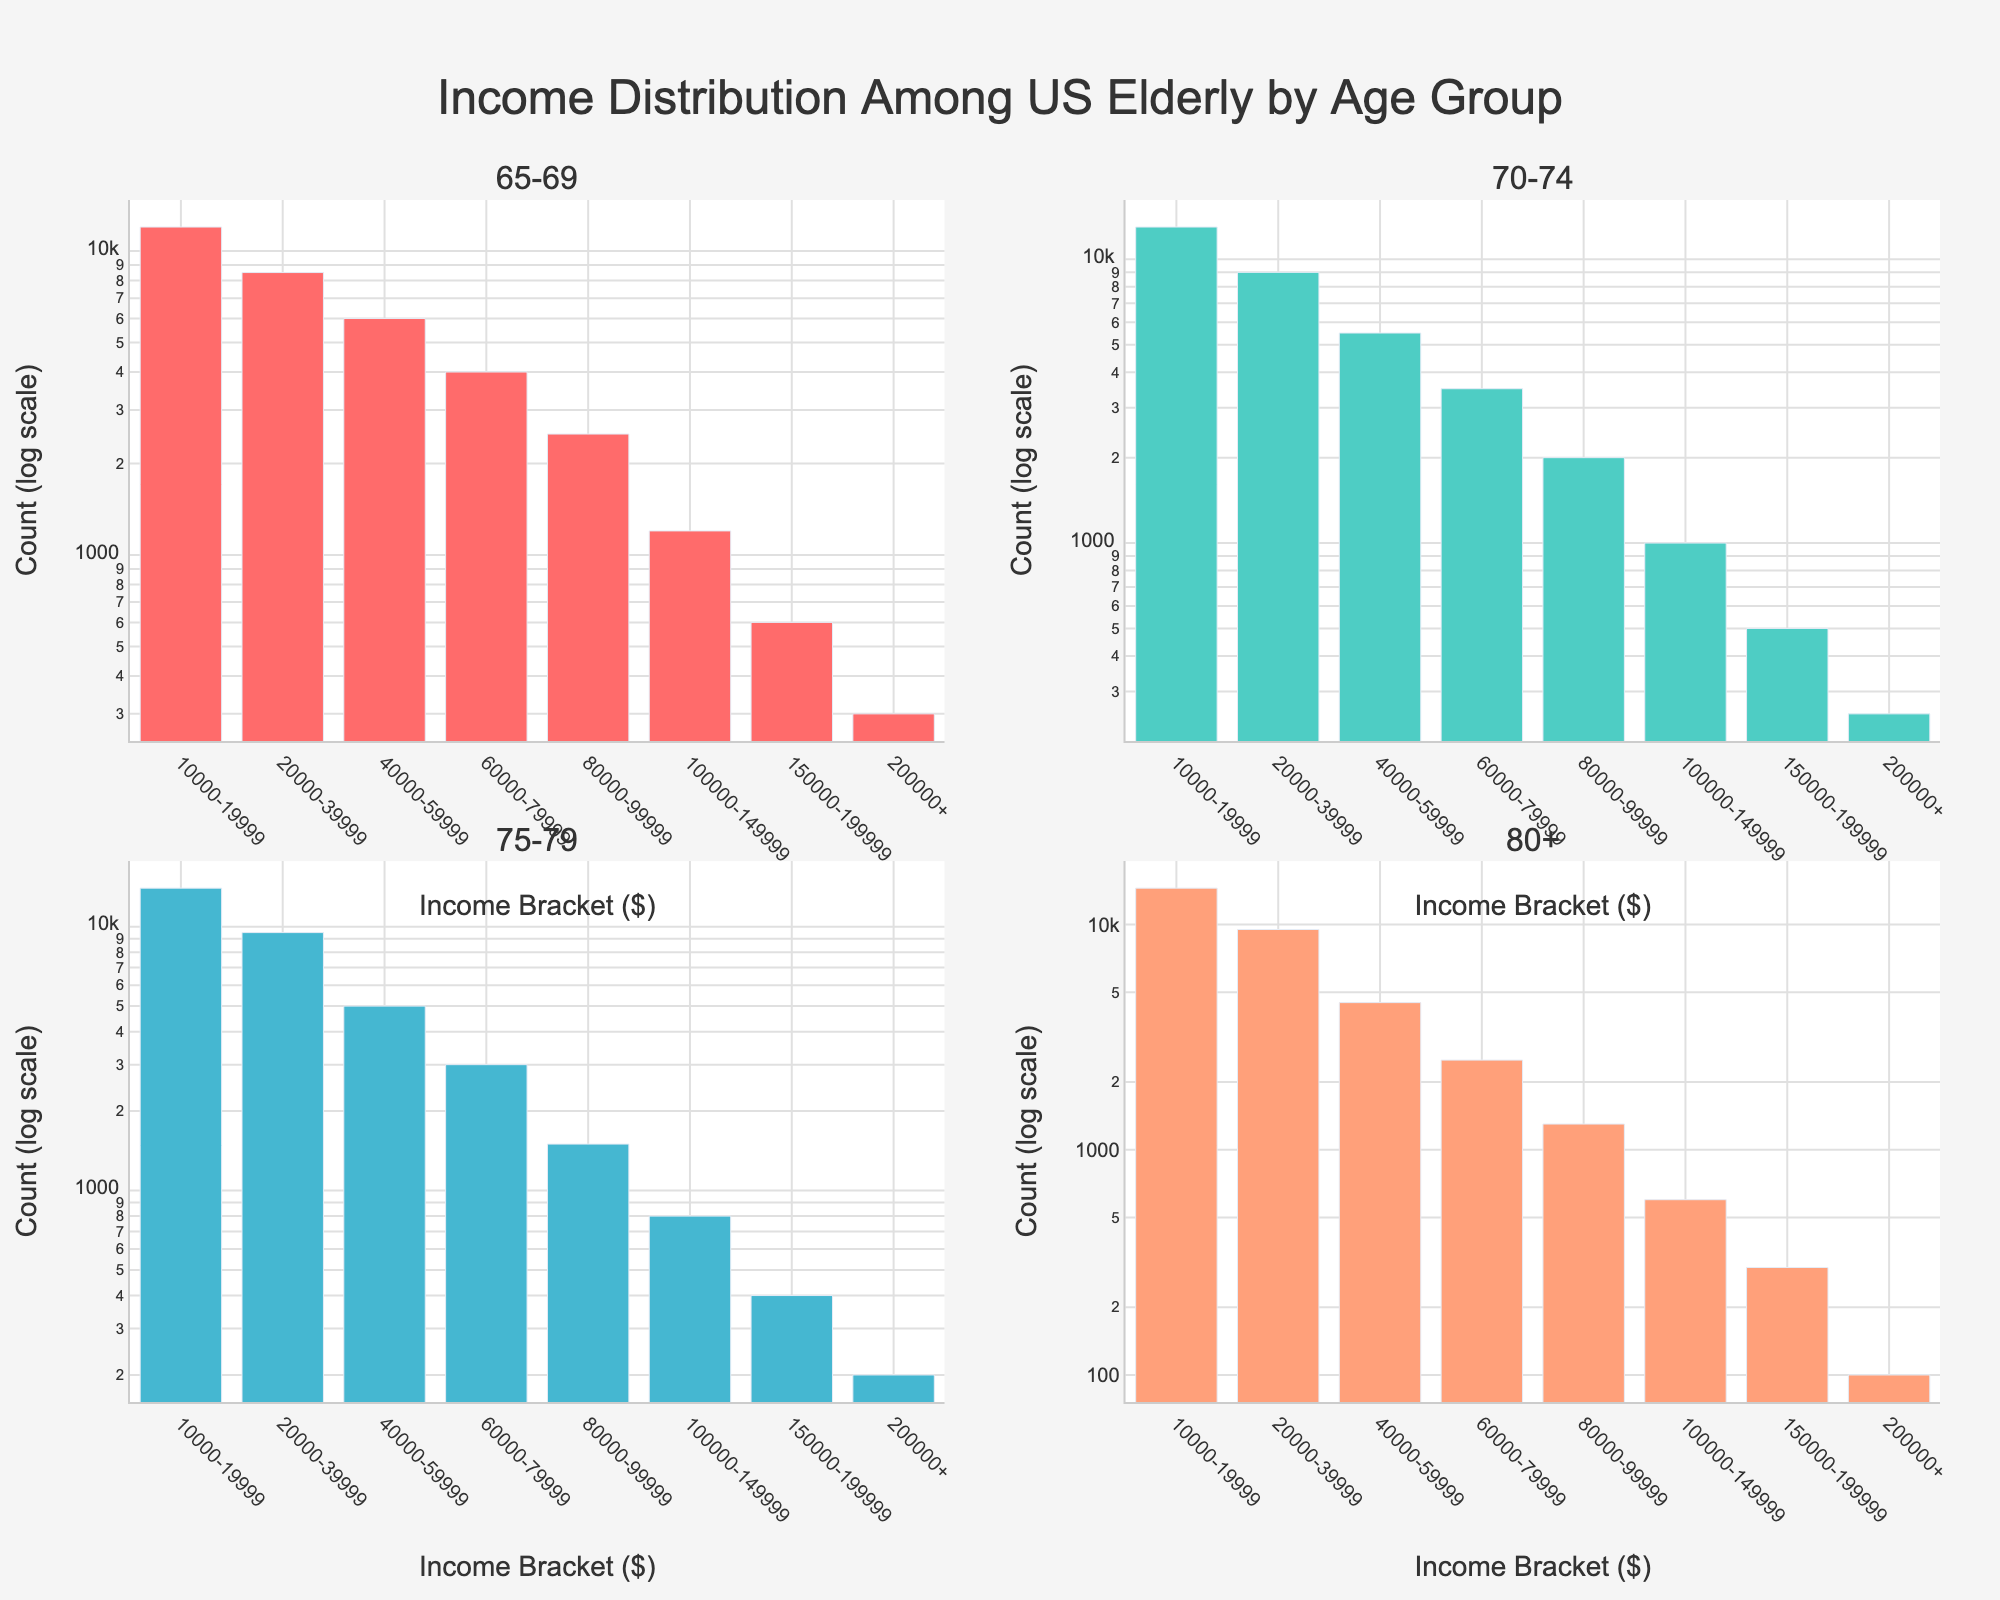what is the title of the figure? The title is displayed at the top of the figure.
Answer: Income Distribution Among US Elderly by Age Group How many age groups are represented in the plot? There are four subplots, each representing a different age group: 65-69, 70-74, 75-79, and 80+.
Answer: Four Which age group has the highest count in the lowest income bracket ($10,000-$19,999)? The bar representing the $10,000-$19,999 income bracket in the subplot for age group 80+ is the tallest among all similar brackets.
Answer: 80+ What is the count for the $100,000-$149,999 income bracket in the 75-79 age group? In the subplot for 75-79, the bar corresponding to the $100,000-$149,999 income bracket shows the count on the log scale.
Answer: 800 Compare the counts for the $60,000-$79,999 income bracket across all age groups, which has the highest and which has the lowest? Look at the bar heights for the $60,000-$79,999 income bracket in each subplot. 65-69 has the highest bar and 80+ has the lowest.
Answer: Highest: 65-69, Lowest: 80+ What can you say about the general shape or trend of the distribution of income among the age groups? The bars are generally higher for lower income brackets and decrease as income increases across all age groups, indicating a higher concentration of elderly individuals in lower income brackets.
Answer: Trend: Higher concentration in lower income brackets Which age group has the smallest count for the income bracket $150,000-$199,999? The smallest bar for $150,000-$199,999 appears in the subplot for the 80+ age group.
Answer: 80+ How does the count for the $200,000+ income bracket in the 70-74 age group compare to the 65-69 age group? By comparing the bars for the $200,000+ income bracket in both subplots, the bar for 65-69 is slightly taller than that of 70-74.
Answer: 65-69 > 70-74 Across all age groups, what is the income bracket with the highest total count? Summing up the counts for each income bracket across all subplots, the $10,000-$19,999 bracket clearly has the highest total.
Answer: $10,000-$19,999 Which age group shows the most significant decrease in count from the lowest to the highest income bracket? Comparing the heights of the bars from the lowest to the highest income bracket in each subplot, the age group 80+ shows a notable decrease.
Answer: 80+ 